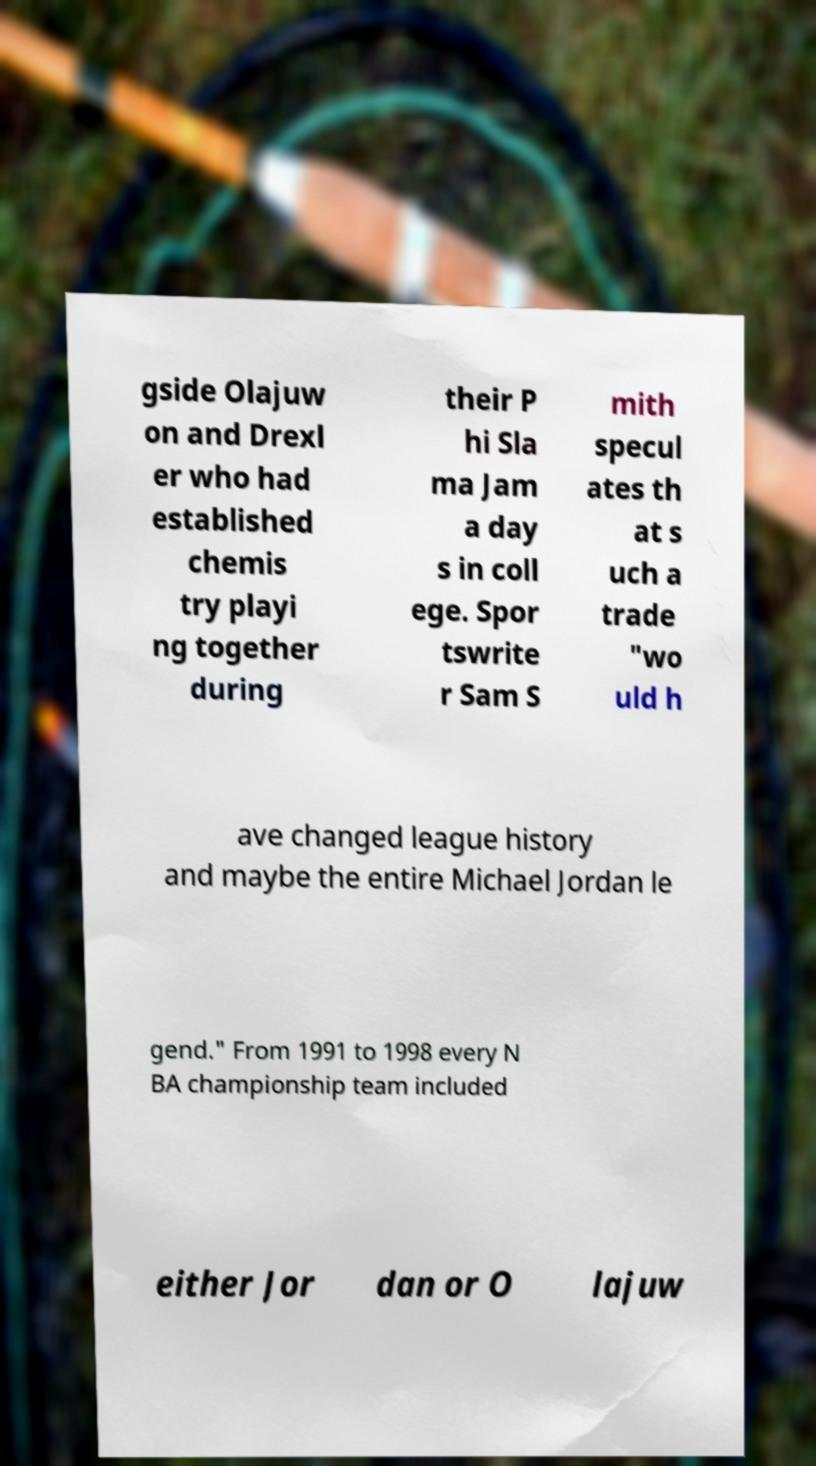For documentation purposes, I need the text within this image transcribed. Could you provide that? gside Olajuw on and Drexl er who had established chemis try playi ng together during their P hi Sla ma Jam a day s in coll ege. Spor tswrite r Sam S mith specul ates th at s uch a trade "wo uld h ave changed league history and maybe the entire Michael Jordan le gend." From 1991 to 1998 every N BA championship team included either Jor dan or O lajuw 